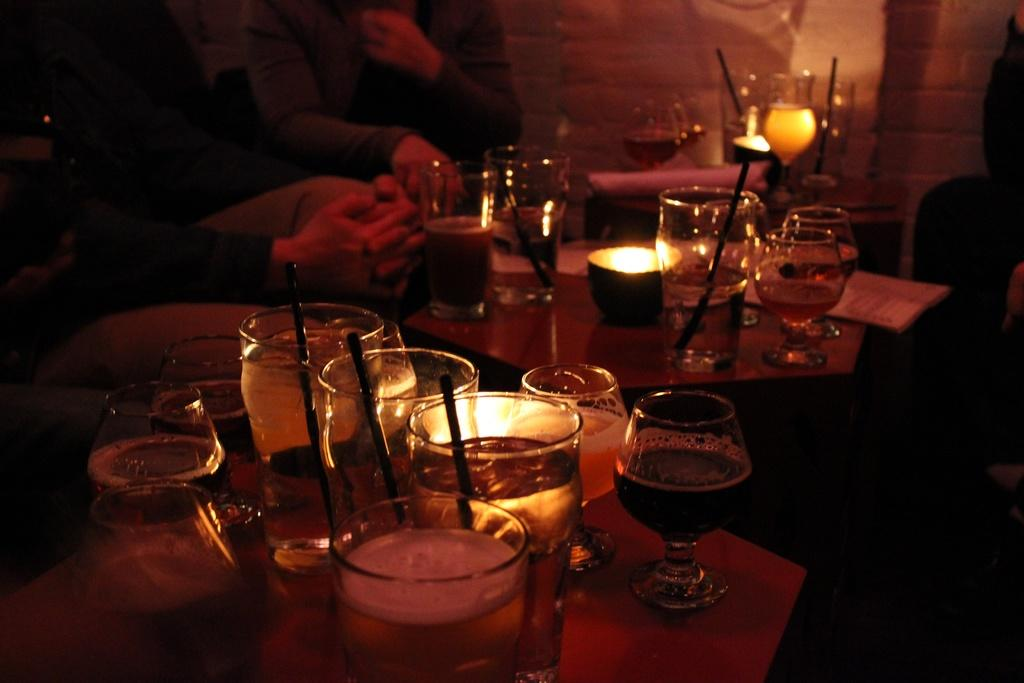What are the people in the image doing? The people in the image are sitting. Where are the people sitting in relation to the table? The people are sitting in front of a table. What objects can be seen on the table? There are glasses on the table. What type of lock is visible on the daughter's zoo cage in the image? There is no daughter, zoo, or lock present in the image. 